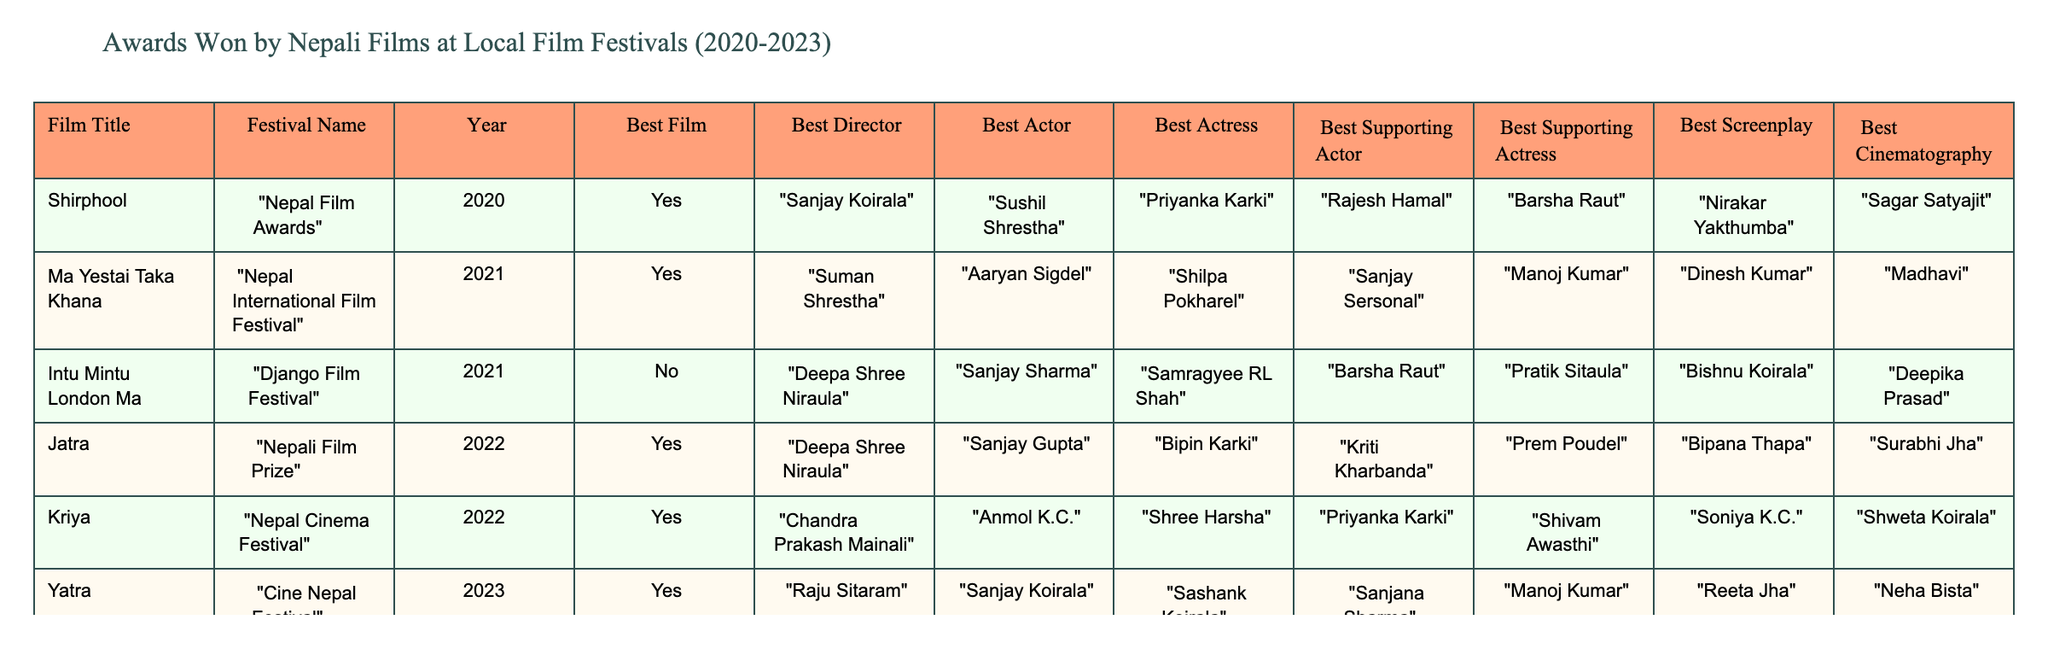What film won Best Film at the Kathmandu International Film Festival in 2023? The table indicates that "Pashupati Prasad 2" won the Best Film award at the Kathmandu International Film Festival in 2023.
Answer: Pashupati Prasad 2 Which year had the most films winning the Best Film award? By examining the table, I can see that both 2022 and 2023 each had three films winning the Best Film award. Therefore, the years with the most films winning the award are 2022 and 2023.
Answer: 2022 and 2023 Did "Jatra" win Best Director at any festival? According to the table, "Jatra" won Best Director at the Nepali Film Prize in 2022, as indicated in the relevant column of the table.
Answer: Yes Which actor won Best Supporting Actress for "Intu Mintu London Ma"? The table shows that "Intu Mintu London Ma" did not win any awards, including Best Supporting Actress. Therefore, the answer is that no actress won this award for that film.
Answer: No What is the total number of Best Actor awards won by films in 2021? From the table, in 2021, "Ma Yestai Taka Khana" won Best Actor (Aaryan Sigdel), while "Intu Mintu London Ma" did not win. Thus, only one film won the Best Actor award in 2021.
Answer: 1 What was the best film of 2022 at the Nepali Film Prize? The table indicates that "Jatra" won the Best Film award at the Nepali Film Prize in 2022.
Answer: Jatra Compare the number of awards won by "Kriya" and "Yatra". Which film won more awards? "Kriya" won four awards (Best Film, Best Director, Best Actor, and Best Actress), while "Yatra" also won four awards (Best Film, Best Director, Best Actor, and Best Supporting Actress), so they both won the same number of awards.
Answer: They both won the same number of awards Which actress won Best Supporting Actress in 2023? The table indicates that "Sanjana Sharma" won the Best Supporting Actress award for "Yatra" at the Cine Nepal Festival in 2023.
Answer: Sanjana Sharma What can you infer about the directors from 2020 to 2023? The table shows that multiple directors have won in the given period: Sanjay Koirala, Suman Shrestha, Deepa Shree Niraula, Chandra Prakash Mainali, Raju Sitaram, and Dibesh Khadka. It's evident that directors from various backgrounds are being recognized across different films. There is no single dominant director.
Answer: Multiple directors are recognized In which festival did "Shirphool" win its awards and how many awards did it win? "Shirphool" won its awards at the Nepal Film Awards in 2020, where it won six awards (Best Film, Best Director, Best Actor, Best Actress, Best Supporting Actor, Best Screenplay).
Answer: Six awards at Nepal Film Awards 